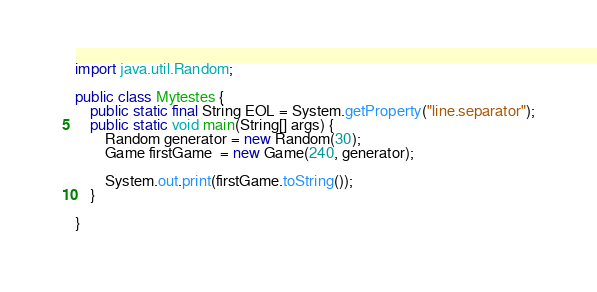<code> <loc_0><loc_0><loc_500><loc_500><_Java_>import java.util.Random;

public class Mytestes {
	public static final String EOL = System.getProperty("line.separator");
	public static void main(String[] args) {
		Random generator = new Random(30);
		Game firstGame  = new Game(240, generator);
		
		System.out.print(firstGame.toString());
	}

}
</code> 